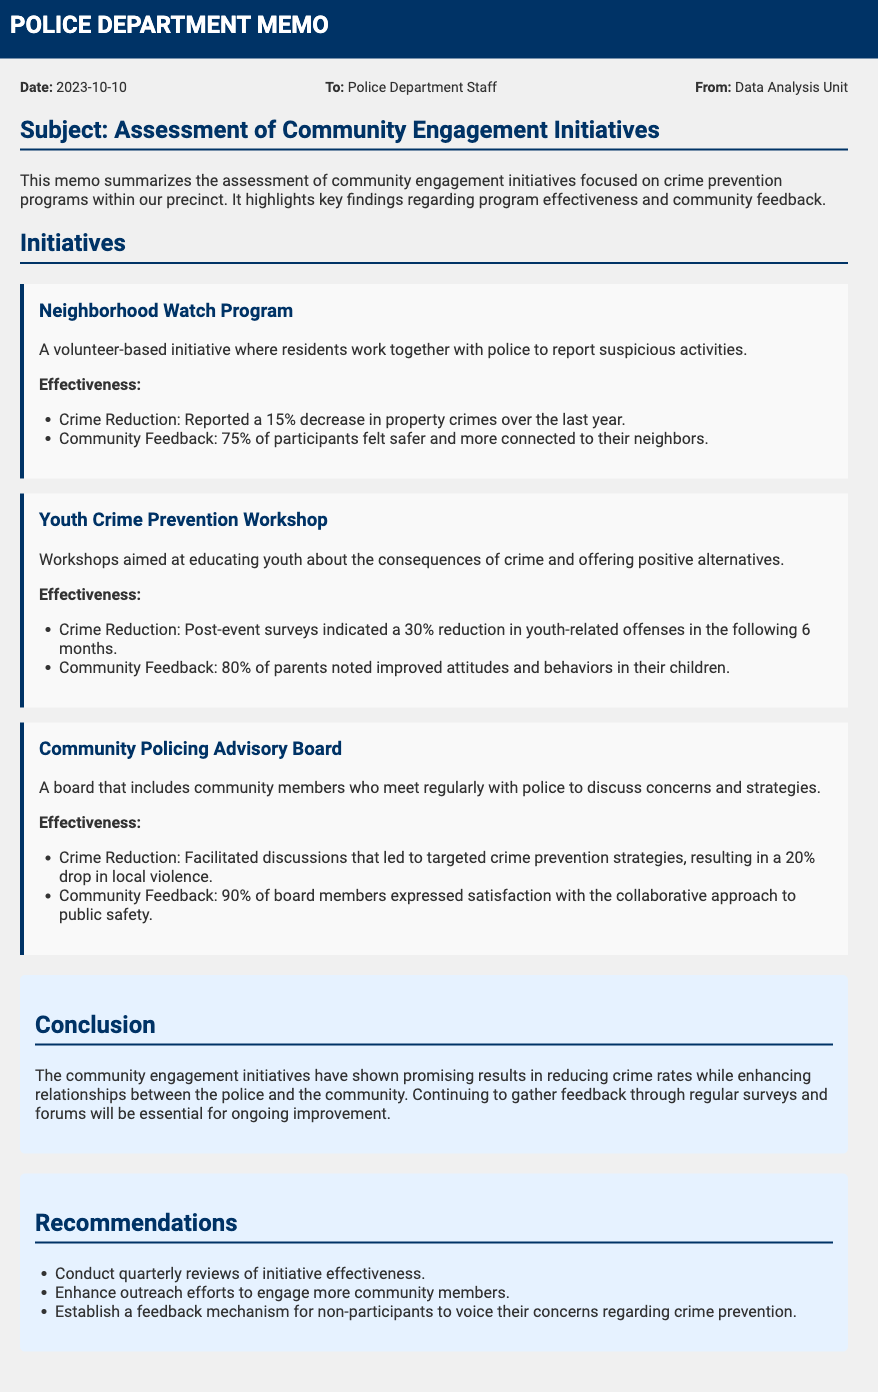What is the date of the memo? The date of the memo is provided in the meta section, which specifies the date as when the memo was created.
Answer: 2023-10-10 What initiative saw a 15% decrease in property crimes? The initiative is specifically mentioned in the document, highlighting its reported impact on crime rates.
Answer: Neighborhood Watch Program What percentage of parents noted improved attitudes and behaviors in their children after the Youth Crime Prevention Workshop? This information is found in the effectiveness section related to the workshop initiative, showing community feedback regarding the program's impact.
Answer: 80% What was the drop in local violence attributed to the Community Policing Advisory Board? The document provides statistics on the effectiveness of the advisory board in terms of crime reduction within the community.
Answer: 20% What does the conclusion suggest about future improvements? It emphasizes the importance of gathering ongoing feedback for enhancements in community engagement and policing strategies.
Answer: Regular surveys and forums How many initiatives are listed in the document? This information can be counted directly from the initiatives section, which enumerates the programs assessed in this memo.
Answer: Three 